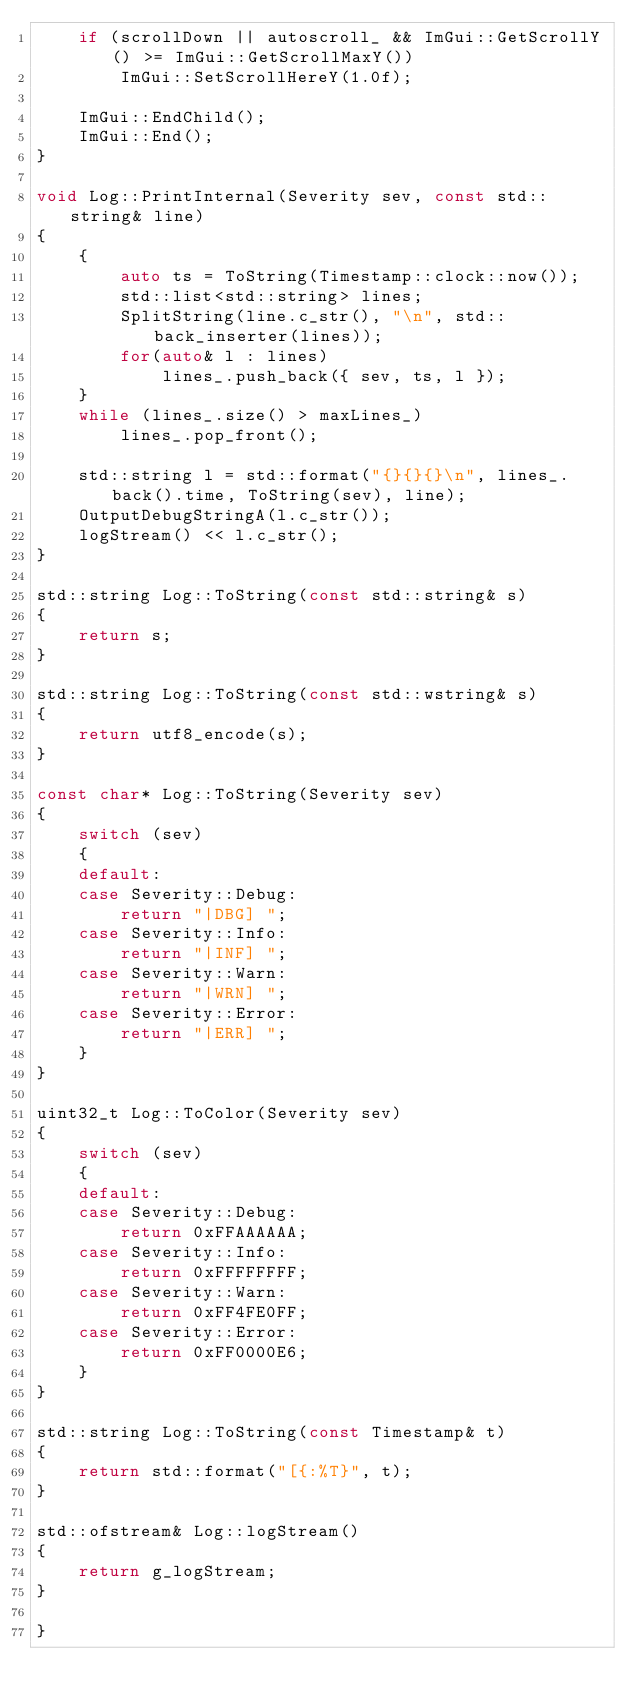Convert code to text. <code><loc_0><loc_0><loc_500><loc_500><_C++_>    if (scrollDown || autoscroll_ && ImGui::GetScrollY() >= ImGui::GetScrollMaxY())
        ImGui::SetScrollHereY(1.0f);

    ImGui::EndChild();
    ImGui::End();
}

void Log::PrintInternal(Severity sev, const std::string& line)
{
    {
        auto ts = ToString(Timestamp::clock::now());
        std::list<std::string> lines;
        SplitString(line.c_str(), "\n", std::back_inserter(lines));
        for(auto& l : lines)
            lines_.push_back({ sev, ts, l });
    }
    while (lines_.size() > maxLines_)
        lines_.pop_front();

    std::string l = std::format("{}{}{}\n", lines_.back().time, ToString(sev), line);
    OutputDebugStringA(l.c_str());
    logStream() << l.c_str();
}

std::string Log::ToString(const std::string& s)
{
    return s;
}

std::string Log::ToString(const std::wstring& s)
{
    return utf8_encode(s);
}

const char* Log::ToString(Severity sev)
{
    switch (sev)
    {
    default:
    case Severity::Debug:
        return "|DBG] ";
    case Severity::Info:
        return "|INF] ";
    case Severity::Warn:
        return "|WRN] ";
    case Severity::Error:
        return "|ERR] ";
    }
}

uint32_t Log::ToColor(Severity sev)
{
    switch (sev)
    {
    default:
    case Severity::Debug:
        return 0xFFAAAAAA;
    case Severity::Info:
        return 0xFFFFFFFF;
    case Severity::Warn:
        return 0xFF4FE0FF;
    case Severity::Error:
        return 0xFF0000E6;
    }
}

std::string Log::ToString(const Timestamp& t)
{
    return std::format("[{:%T}", t);
}

std::ofstream& Log::logStream()
{
    return g_logStream;
}

}
</code> 